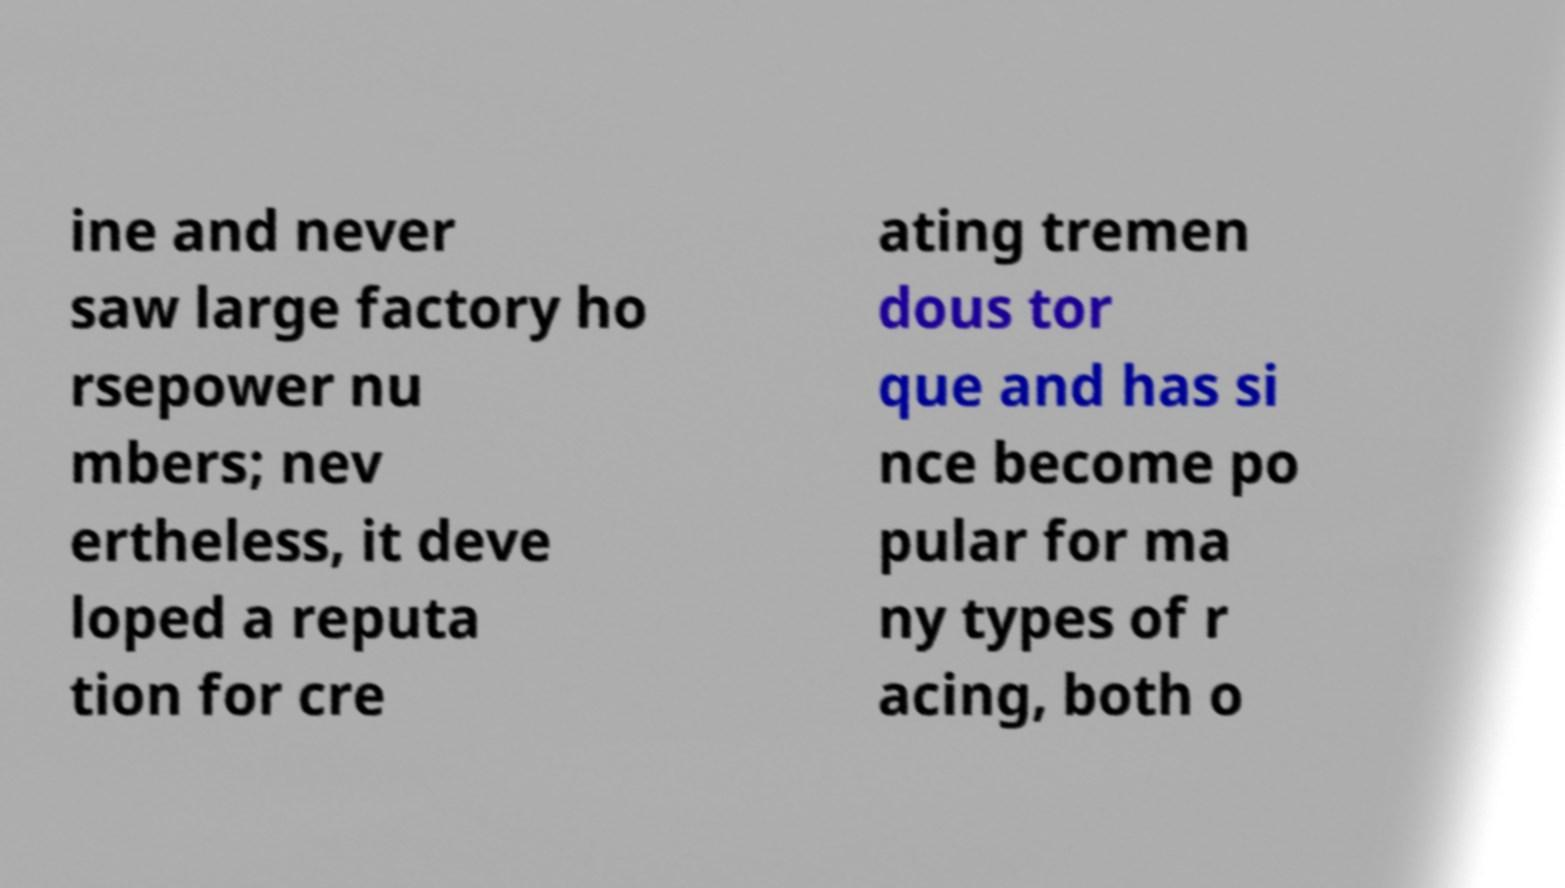What messages or text are displayed in this image? I need them in a readable, typed format. ine and never saw large factory ho rsepower nu mbers; nev ertheless, it deve loped a reputa tion for cre ating tremen dous tor que and has si nce become po pular for ma ny types of r acing, both o 